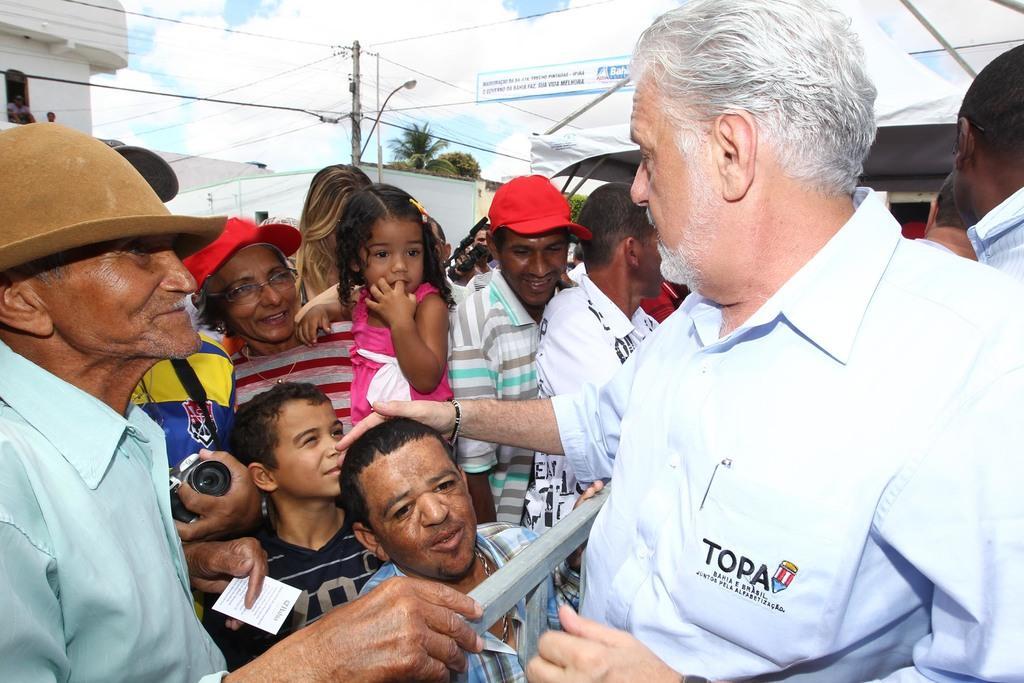Can you describe this image briefly? In the image we can see there are people standing and there is a man in front and he is putting his hand on the head of a person. Behind there are trees, there are buildings and there is an electric light pole. 